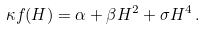<formula> <loc_0><loc_0><loc_500><loc_500>\kappa f ( H ) = \alpha + \beta H ^ { 2 } + \sigma H ^ { 4 } \, .</formula> 